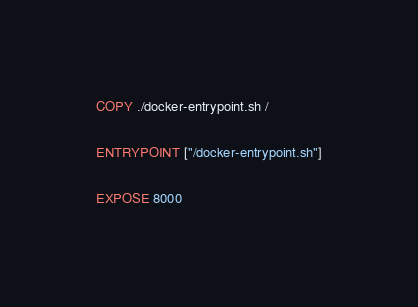<code> <loc_0><loc_0><loc_500><loc_500><_Dockerfile_>
COPY ./docker-entrypoint.sh /

ENTRYPOINT ["/docker-entrypoint.sh"]

EXPOSE 8000
</code> 